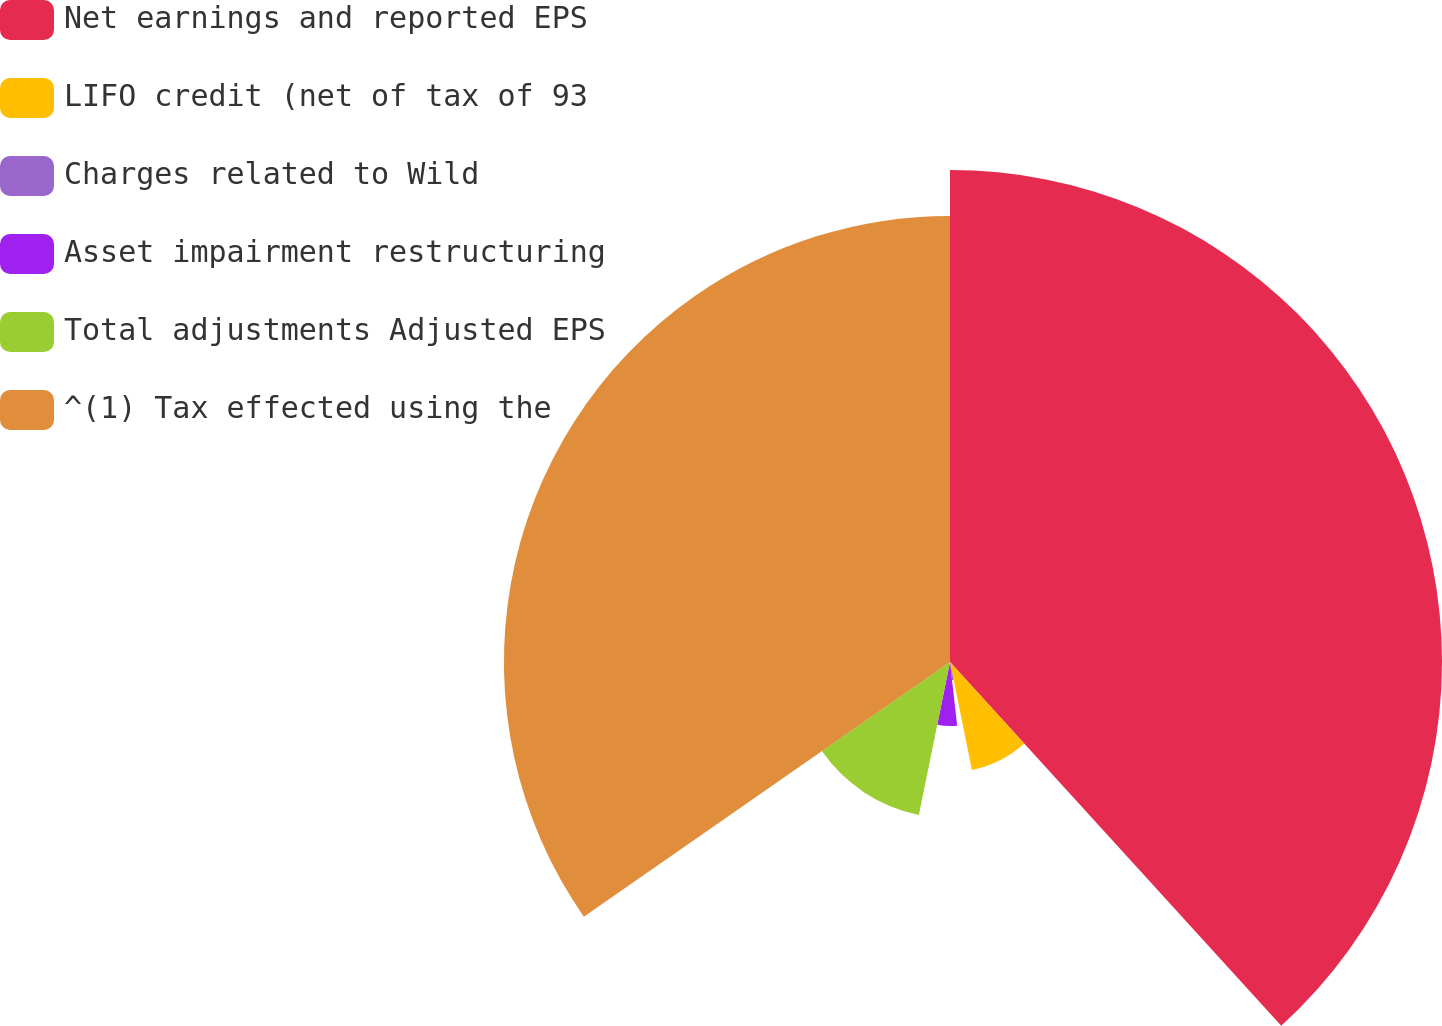Convert chart. <chart><loc_0><loc_0><loc_500><loc_500><pie_chart><fcel>Net earnings and reported EPS<fcel>LIFO credit (net of tax of 93<fcel>Charges related to Wild<fcel>Asset impairment restructuring<fcel>Total adjustments Adjusted EPS<fcel>^(1) Tax effected using the<nl><fcel>38.24%<fcel>8.56%<fcel>1.41%<fcel>4.98%<fcel>12.13%<fcel>34.67%<nl></chart> 